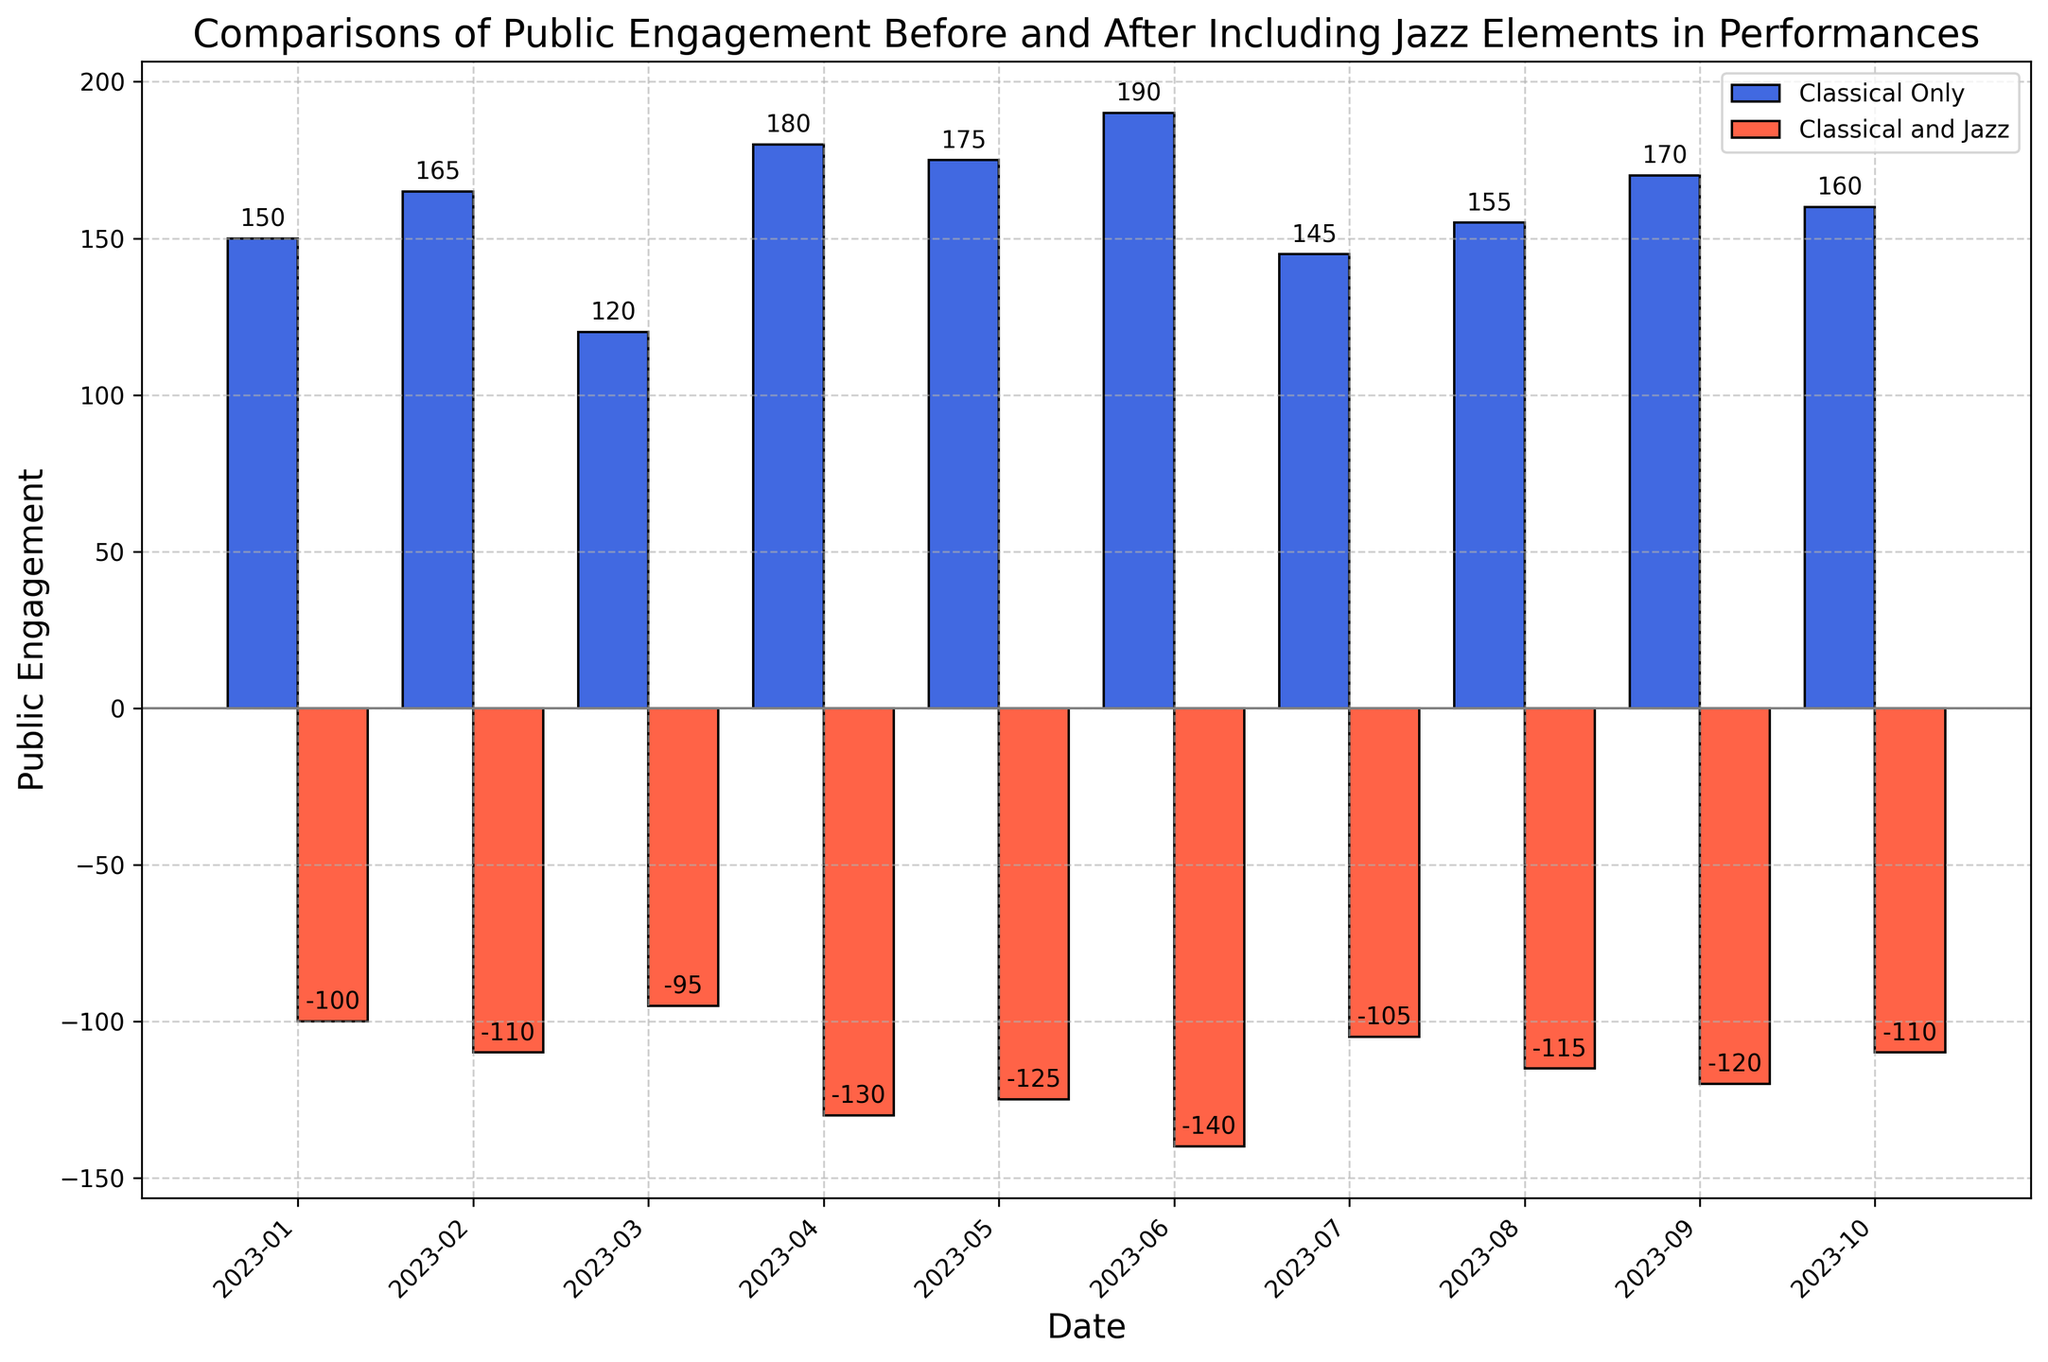What's the highest public engagement value recorded for 'Classical Only' performances? Look at the bar corresponding to 'Classical Only' across all months and the tallest blue bar is in June 2023, where the value is 190.
Answer: 190 Which performance style had the least public engagement in July 2023? Compare the heights of the bars for 'Classical Only' (blue) and 'Classical and Jazz' (red) in July 2023. The red bar representing 'Classical and Jazz' is lower with a value of -105.
Answer: Classical and Jazz Is there any month where the public engagement value for 'Classical Only' and 'Classical and Jazz' both showed a decrease? Look for movements of bars below the x-axis for 'Classical and Jazz' and between months for 'Classical Only'. There is no such month; 'Classical Only' does not go below zero.
Answer: No What's the difference in public engagement between 'Classical Only' and 'Classical and Jazz' in April 2023? The values for April 2023 are 180 for 'Classical Only' and -130 for 'Classical and Jazz'. The difference is calculated as 180 - (-130) = 310.
Answer: 310 What is the average public engagement for 'Classical Only' performances from January to June 2023? Sum the values of public engagement for 'Classical Only' from January to June 2023, which is 150 + 165 + 120 + 180 + 175 + 190 = 980, then divide by 6: 980 / 6 = approximately 163.33.
Answer: Approximately 163.33 In which month is the engagement gap between 'Classical Only' and 'Classical and Jazz' the smallest? To find the smallest gap, calculate the difference for each month and compare. For example, in January 2023 the gap is 150 - (-100) = 250, in February 2023 it is 165 - (-110) = 275, etc. The smallest gap is in March 2023 with a difference of 120 - (-95) = 215.
Answer: March 2023 Which month shows the sharpest increase in public engagement for 'Classical Only' performances compared to the previous month? Calculate month-over-month differences for 'Classical Only' values and identify the largest increase. The differences are: Feb-Jan = 15, Mar-Feb = -45, Apr-Mar = 60, May-Apr = -5, Jun-May = 15. The sharpest increase is April 2023 with 60.
Answer: April 2023 